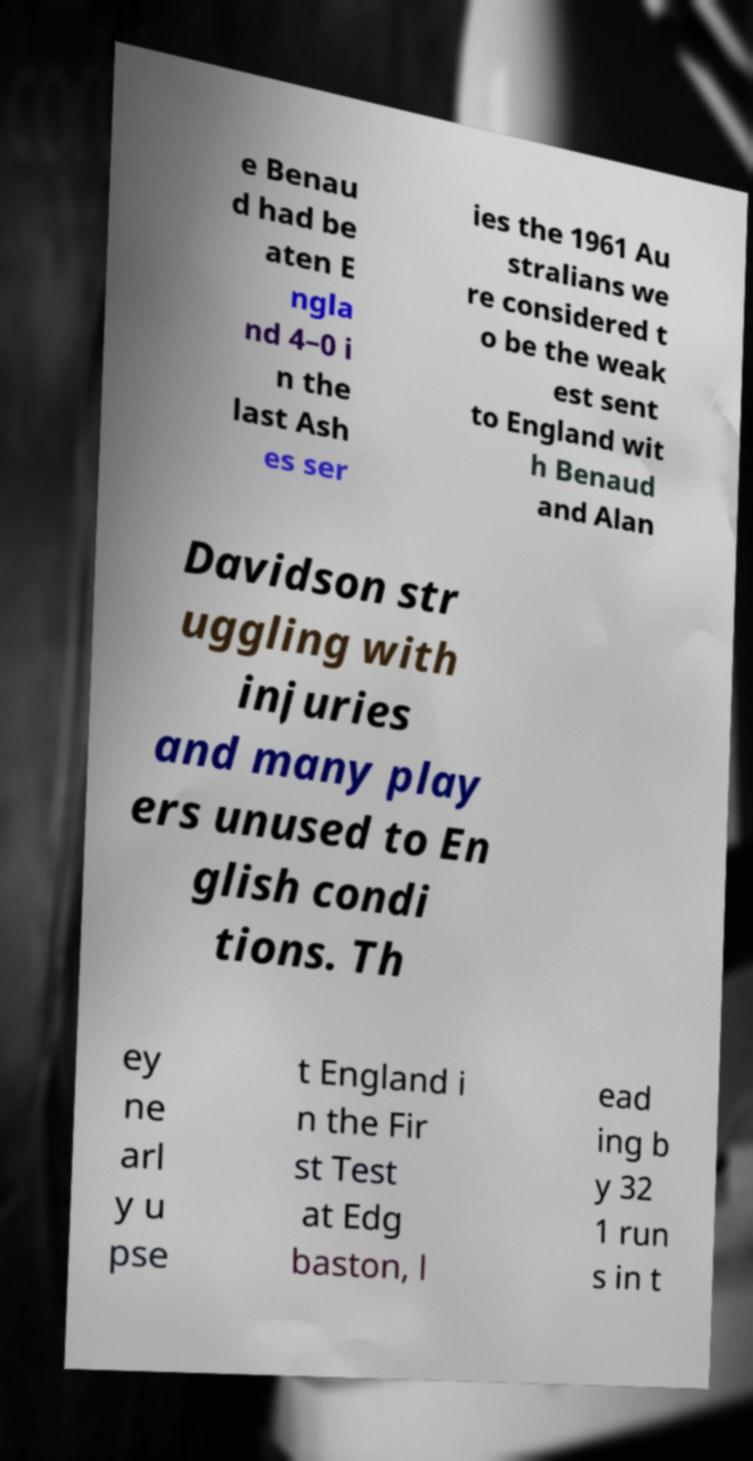Please read and relay the text visible in this image. What does it say? e Benau d had be aten E ngla nd 4–0 i n the last Ash es ser ies the 1961 Au stralians we re considered t o be the weak est sent to England wit h Benaud and Alan Davidson str uggling with injuries and many play ers unused to En glish condi tions. Th ey ne arl y u pse t England i n the Fir st Test at Edg baston, l ead ing b y 32 1 run s in t 